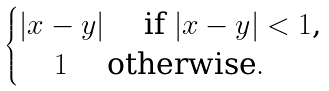<formula> <loc_0><loc_0><loc_500><loc_500>\begin{cases} | x - y | \quad \text { if $|x-y|<1$,} \\ \quad \, 1 \quad \text {   otherwise} . \end{cases}</formula> 